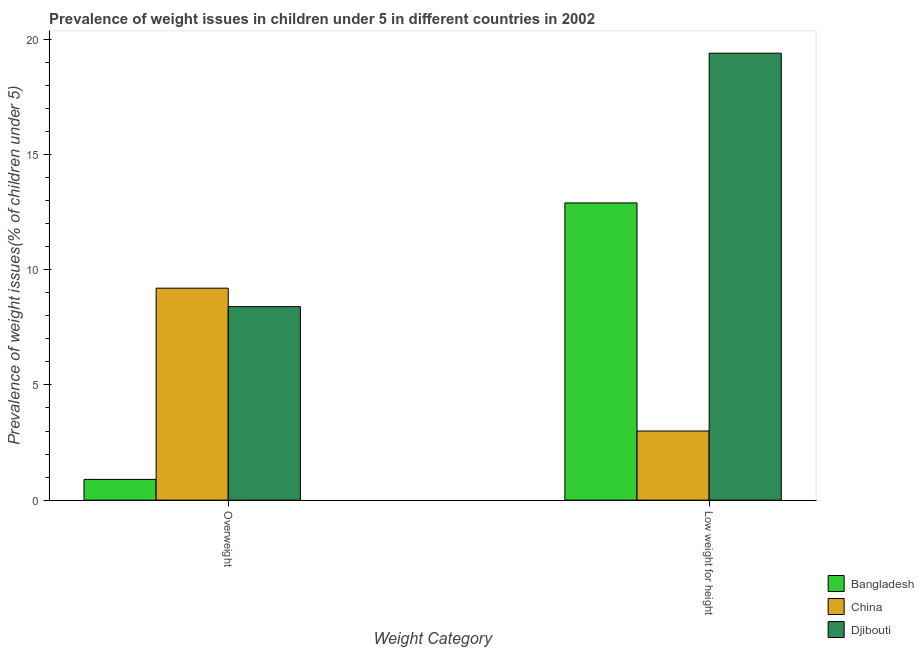How many different coloured bars are there?
Offer a very short reply. 3. How many groups of bars are there?
Provide a short and direct response. 2. Are the number of bars per tick equal to the number of legend labels?
Your answer should be very brief. Yes. How many bars are there on the 2nd tick from the left?
Keep it short and to the point. 3. What is the label of the 1st group of bars from the left?
Your response must be concise. Overweight. What is the percentage of overweight children in Bangladesh?
Give a very brief answer. 0.9. Across all countries, what is the maximum percentage of overweight children?
Your answer should be very brief. 9.2. Across all countries, what is the minimum percentage of overweight children?
Give a very brief answer. 0.9. In which country was the percentage of underweight children maximum?
Provide a short and direct response. Djibouti. What is the total percentage of overweight children in the graph?
Offer a terse response. 18.5. What is the difference between the percentage of overweight children in China and that in Djibouti?
Offer a very short reply. 0.8. What is the difference between the percentage of overweight children in Djibouti and the percentage of underweight children in China?
Make the answer very short. 5.4. What is the average percentage of overweight children per country?
Provide a succinct answer. 6.17. What is the difference between the percentage of underweight children and percentage of overweight children in Djibouti?
Offer a very short reply. 11. In how many countries, is the percentage of overweight children greater than 3 %?
Give a very brief answer. 2. What is the ratio of the percentage of underweight children in China to that in Bangladesh?
Offer a terse response. 0.23. Is the percentage of overweight children in Djibouti less than that in Bangladesh?
Provide a short and direct response. No. In how many countries, is the percentage of underweight children greater than the average percentage of underweight children taken over all countries?
Offer a terse response. 2. What does the 3rd bar from the left in Overweight represents?
Your response must be concise. Djibouti. Are all the bars in the graph horizontal?
Your answer should be very brief. No. How many countries are there in the graph?
Ensure brevity in your answer.  3. What is the difference between two consecutive major ticks on the Y-axis?
Your answer should be compact. 5. Does the graph contain any zero values?
Your answer should be compact. No. Does the graph contain grids?
Provide a succinct answer. No. How many legend labels are there?
Your answer should be very brief. 3. What is the title of the graph?
Give a very brief answer. Prevalence of weight issues in children under 5 in different countries in 2002. Does "Nicaragua" appear as one of the legend labels in the graph?
Provide a short and direct response. No. What is the label or title of the X-axis?
Offer a terse response. Weight Category. What is the label or title of the Y-axis?
Offer a very short reply. Prevalence of weight issues(% of children under 5). What is the Prevalence of weight issues(% of children under 5) in Bangladesh in Overweight?
Your response must be concise. 0.9. What is the Prevalence of weight issues(% of children under 5) of China in Overweight?
Keep it short and to the point. 9.2. What is the Prevalence of weight issues(% of children under 5) in Djibouti in Overweight?
Provide a short and direct response. 8.4. What is the Prevalence of weight issues(% of children under 5) of Bangladesh in Low weight for height?
Make the answer very short. 12.9. What is the Prevalence of weight issues(% of children under 5) in Djibouti in Low weight for height?
Keep it short and to the point. 19.4. Across all Weight Category, what is the maximum Prevalence of weight issues(% of children under 5) in Bangladesh?
Ensure brevity in your answer.  12.9. Across all Weight Category, what is the maximum Prevalence of weight issues(% of children under 5) of China?
Give a very brief answer. 9.2. Across all Weight Category, what is the maximum Prevalence of weight issues(% of children under 5) in Djibouti?
Ensure brevity in your answer.  19.4. Across all Weight Category, what is the minimum Prevalence of weight issues(% of children under 5) of Bangladesh?
Provide a succinct answer. 0.9. Across all Weight Category, what is the minimum Prevalence of weight issues(% of children under 5) of Djibouti?
Your answer should be compact. 8.4. What is the total Prevalence of weight issues(% of children under 5) of Bangladesh in the graph?
Offer a very short reply. 13.8. What is the total Prevalence of weight issues(% of children under 5) of China in the graph?
Keep it short and to the point. 12.2. What is the total Prevalence of weight issues(% of children under 5) in Djibouti in the graph?
Provide a short and direct response. 27.8. What is the difference between the Prevalence of weight issues(% of children under 5) in Bangladesh in Overweight and the Prevalence of weight issues(% of children under 5) in Djibouti in Low weight for height?
Your answer should be compact. -18.5. What is the average Prevalence of weight issues(% of children under 5) of Bangladesh per Weight Category?
Give a very brief answer. 6.9. What is the difference between the Prevalence of weight issues(% of children under 5) in Bangladesh and Prevalence of weight issues(% of children under 5) in China in Overweight?
Give a very brief answer. -8.3. What is the difference between the Prevalence of weight issues(% of children under 5) of Bangladesh and Prevalence of weight issues(% of children under 5) of Djibouti in Overweight?
Offer a terse response. -7.5. What is the difference between the Prevalence of weight issues(% of children under 5) in Bangladesh and Prevalence of weight issues(% of children under 5) in China in Low weight for height?
Offer a terse response. 9.9. What is the difference between the Prevalence of weight issues(% of children under 5) of China and Prevalence of weight issues(% of children under 5) of Djibouti in Low weight for height?
Your response must be concise. -16.4. What is the ratio of the Prevalence of weight issues(% of children under 5) of Bangladesh in Overweight to that in Low weight for height?
Your answer should be very brief. 0.07. What is the ratio of the Prevalence of weight issues(% of children under 5) of China in Overweight to that in Low weight for height?
Offer a terse response. 3.07. What is the ratio of the Prevalence of weight issues(% of children under 5) in Djibouti in Overweight to that in Low weight for height?
Ensure brevity in your answer.  0.43. What is the difference between the highest and the lowest Prevalence of weight issues(% of children under 5) in China?
Provide a short and direct response. 6.2. 